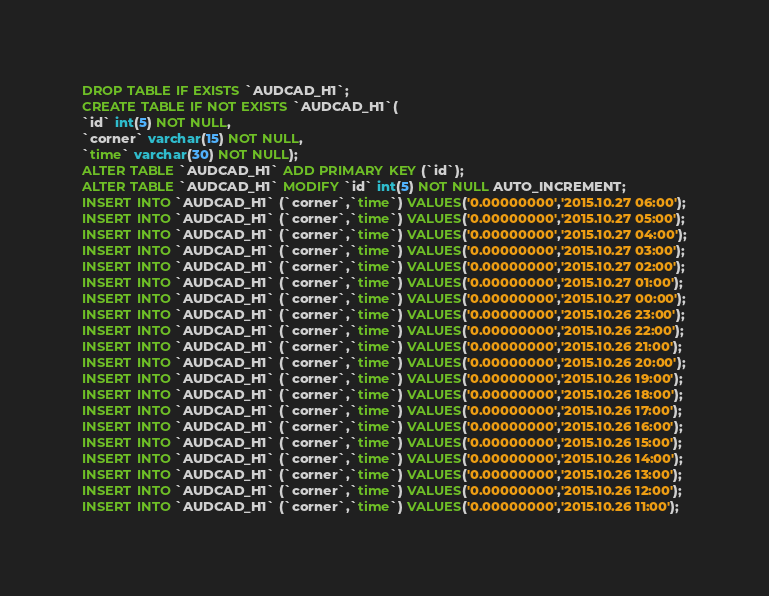Convert code to text. <code><loc_0><loc_0><loc_500><loc_500><_SQL_>DROP TABLE IF EXISTS `AUDCAD_H1`;
CREATE TABLE IF NOT EXISTS `AUDCAD_H1`(
`id` int(5) NOT NULL,
`corner` varchar(15) NOT NULL,
`time` varchar(30) NOT NULL);
ALTER TABLE `AUDCAD_H1` ADD PRIMARY KEY (`id`);
ALTER TABLE `AUDCAD_H1` MODIFY `id` int(5) NOT NULL AUTO_INCREMENT;
INSERT INTO `AUDCAD_H1` (`corner`,`time`) VALUES('0.00000000','2015.10.27 06:00');
INSERT INTO `AUDCAD_H1` (`corner`,`time`) VALUES('0.00000000','2015.10.27 05:00');
INSERT INTO `AUDCAD_H1` (`corner`,`time`) VALUES('0.00000000','2015.10.27 04:00');
INSERT INTO `AUDCAD_H1` (`corner`,`time`) VALUES('0.00000000','2015.10.27 03:00');
INSERT INTO `AUDCAD_H1` (`corner`,`time`) VALUES('0.00000000','2015.10.27 02:00');
INSERT INTO `AUDCAD_H1` (`corner`,`time`) VALUES('0.00000000','2015.10.27 01:00');
INSERT INTO `AUDCAD_H1` (`corner`,`time`) VALUES('0.00000000','2015.10.27 00:00');
INSERT INTO `AUDCAD_H1` (`corner`,`time`) VALUES('0.00000000','2015.10.26 23:00');
INSERT INTO `AUDCAD_H1` (`corner`,`time`) VALUES('0.00000000','2015.10.26 22:00');
INSERT INTO `AUDCAD_H1` (`corner`,`time`) VALUES('0.00000000','2015.10.26 21:00');
INSERT INTO `AUDCAD_H1` (`corner`,`time`) VALUES('0.00000000','2015.10.26 20:00');
INSERT INTO `AUDCAD_H1` (`corner`,`time`) VALUES('0.00000000','2015.10.26 19:00');
INSERT INTO `AUDCAD_H1` (`corner`,`time`) VALUES('0.00000000','2015.10.26 18:00');
INSERT INTO `AUDCAD_H1` (`corner`,`time`) VALUES('0.00000000','2015.10.26 17:00');
INSERT INTO `AUDCAD_H1` (`corner`,`time`) VALUES('0.00000000','2015.10.26 16:00');
INSERT INTO `AUDCAD_H1` (`corner`,`time`) VALUES('0.00000000','2015.10.26 15:00');
INSERT INTO `AUDCAD_H1` (`corner`,`time`) VALUES('0.00000000','2015.10.26 14:00');
INSERT INTO `AUDCAD_H1` (`corner`,`time`) VALUES('0.00000000','2015.10.26 13:00');
INSERT INTO `AUDCAD_H1` (`corner`,`time`) VALUES('0.00000000','2015.10.26 12:00');
INSERT INTO `AUDCAD_H1` (`corner`,`time`) VALUES('0.00000000','2015.10.26 11:00');</code> 